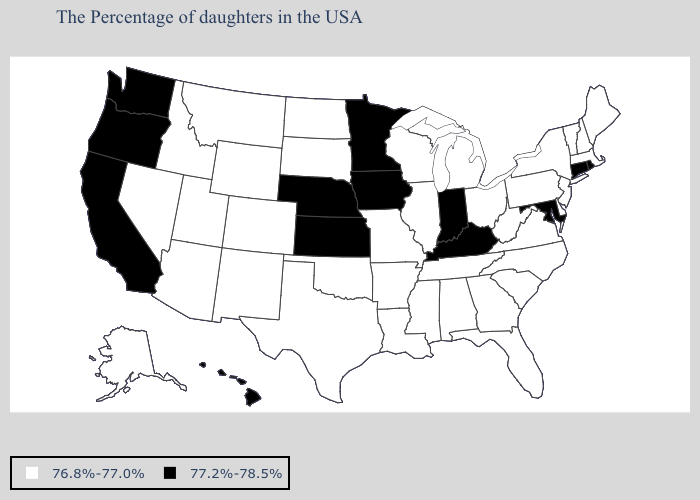What is the lowest value in the South?
Give a very brief answer. 76.8%-77.0%. Does Colorado have the same value as Nevada?
Give a very brief answer. Yes. What is the value of Alabama?
Keep it brief. 76.8%-77.0%. Does the map have missing data?
Concise answer only. No. Name the states that have a value in the range 76.8%-77.0%?
Concise answer only. Maine, Massachusetts, New Hampshire, Vermont, New York, New Jersey, Delaware, Pennsylvania, Virginia, North Carolina, South Carolina, West Virginia, Ohio, Florida, Georgia, Michigan, Alabama, Tennessee, Wisconsin, Illinois, Mississippi, Louisiana, Missouri, Arkansas, Oklahoma, Texas, South Dakota, North Dakota, Wyoming, Colorado, New Mexico, Utah, Montana, Arizona, Idaho, Nevada, Alaska. Does the first symbol in the legend represent the smallest category?
Keep it brief. Yes. Name the states that have a value in the range 77.2%-78.5%?
Concise answer only. Rhode Island, Connecticut, Maryland, Kentucky, Indiana, Minnesota, Iowa, Kansas, Nebraska, California, Washington, Oregon, Hawaii. Name the states that have a value in the range 77.2%-78.5%?
Write a very short answer. Rhode Island, Connecticut, Maryland, Kentucky, Indiana, Minnesota, Iowa, Kansas, Nebraska, California, Washington, Oregon, Hawaii. Name the states that have a value in the range 76.8%-77.0%?
Quick response, please. Maine, Massachusetts, New Hampshire, Vermont, New York, New Jersey, Delaware, Pennsylvania, Virginia, North Carolina, South Carolina, West Virginia, Ohio, Florida, Georgia, Michigan, Alabama, Tennessee, Wisconsin, Illinois, Mississippi, Louisiana, Missouri, Arkansas, Oklahoma, Texas, South Dakota, North Dakota, Wyoming, Colorado, New Mexico, Utah, Montana, Arizona, Idaho, Nevada, Alaska. Name the states that have a value in the range 77.2%-78.5%?
Be succinct. Rhode Island, Connecticut, Maryland, Kentucky, Indiana, Minnesota, Iowa, Kansas, Nebraska, California, Washington, Oregon, Hawaii. What is the value of Iowa?
Answer briefly. 77.2%-78.5%. What is the highest value in the Northeast ?
Be succinct. 77.2%-78.5%. Among the states that border Connecticut , does Massachusetts have the highest value?
Quick response, please. No. 